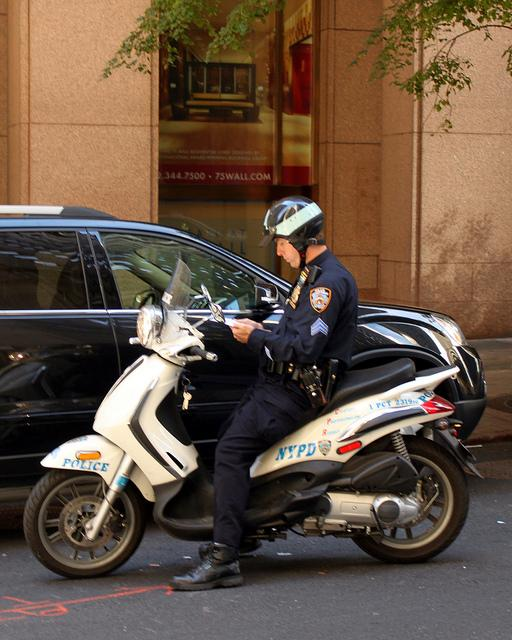Who is on the bicycle?

Choices:
A) rodeo performer
B) police officer
C) actress
D) clown police officer 